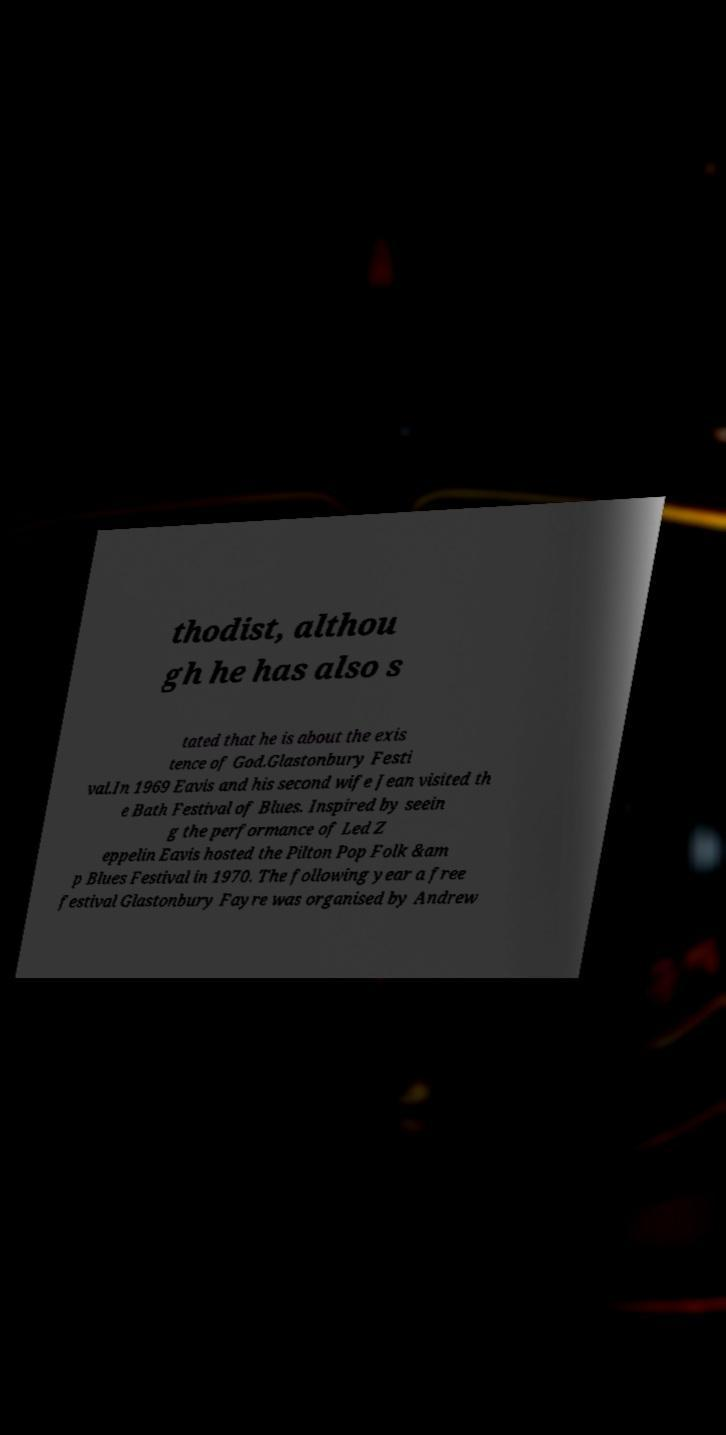Can you accurately transcribe the text from the provided image for me? thodist, althou gh he has also s tated that he is about the exis tence of God.Glastonbury Festi val.In 1969 Eavis and his second wife Jean visited th e Bath Festival of Blues. Inspired by seein g the performance of Led Z eppelin Eavis hosted the Pilton Pop Folk &am p Blues Festival in 1970. The following year a free festival Glastonbury Fayre was organised by Andrew 